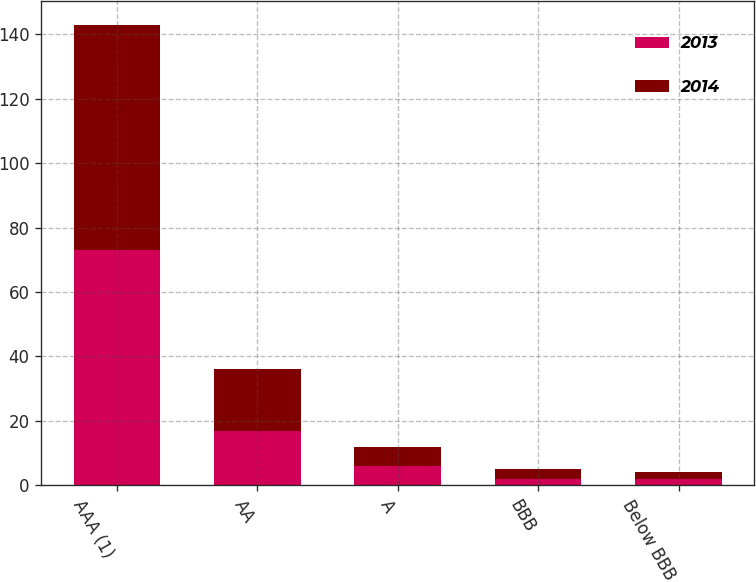Convert chart to OTSL. <chart><loc_0><loc_0><loc_500><loc_500><stacked_bar_chart><ecel><fcel>AAA (1)<fcel>AA<fcel>A<fcel>BBB<fcel>Below BBB<nl><fcel>2013<fcel>73<fcel>17<fcel>6<fcel>2<fcel>2<nl><fcel>2014<fcel>70<fcel>19<fcel>6<fcel>3<fcel>2<nl></chart> 